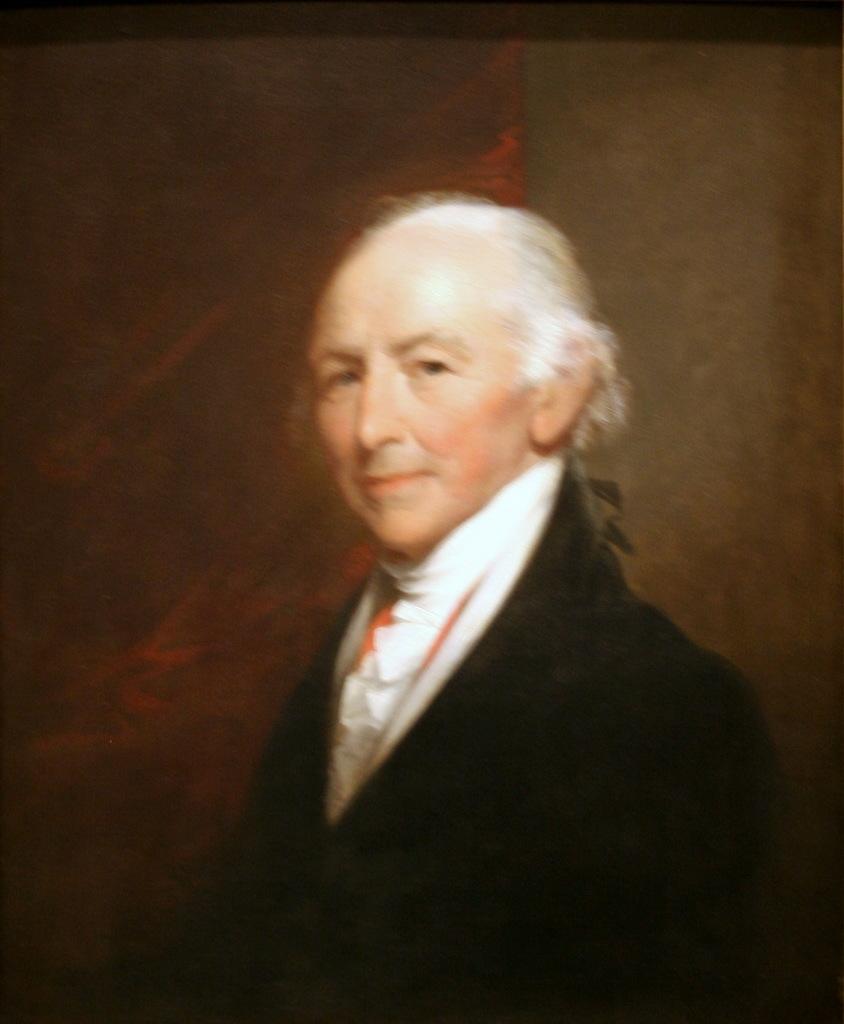How would you summarize this image in a sentence or two? In the image we can see there is a portrait and there is a man. He is wearing formal suit. 